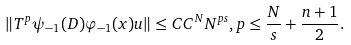<formula> <loc_0><loc_0><loc_500><loc_500>\| T ^ { p } \psi _ { - 1 } ( D ) \varphi _ { - 1 } ( x ) u \| \leq C C ^ { N } N ^ { p s } , p \leq \frac { N } { s } + \frac { n + 1 } { 2 } .</formula> 